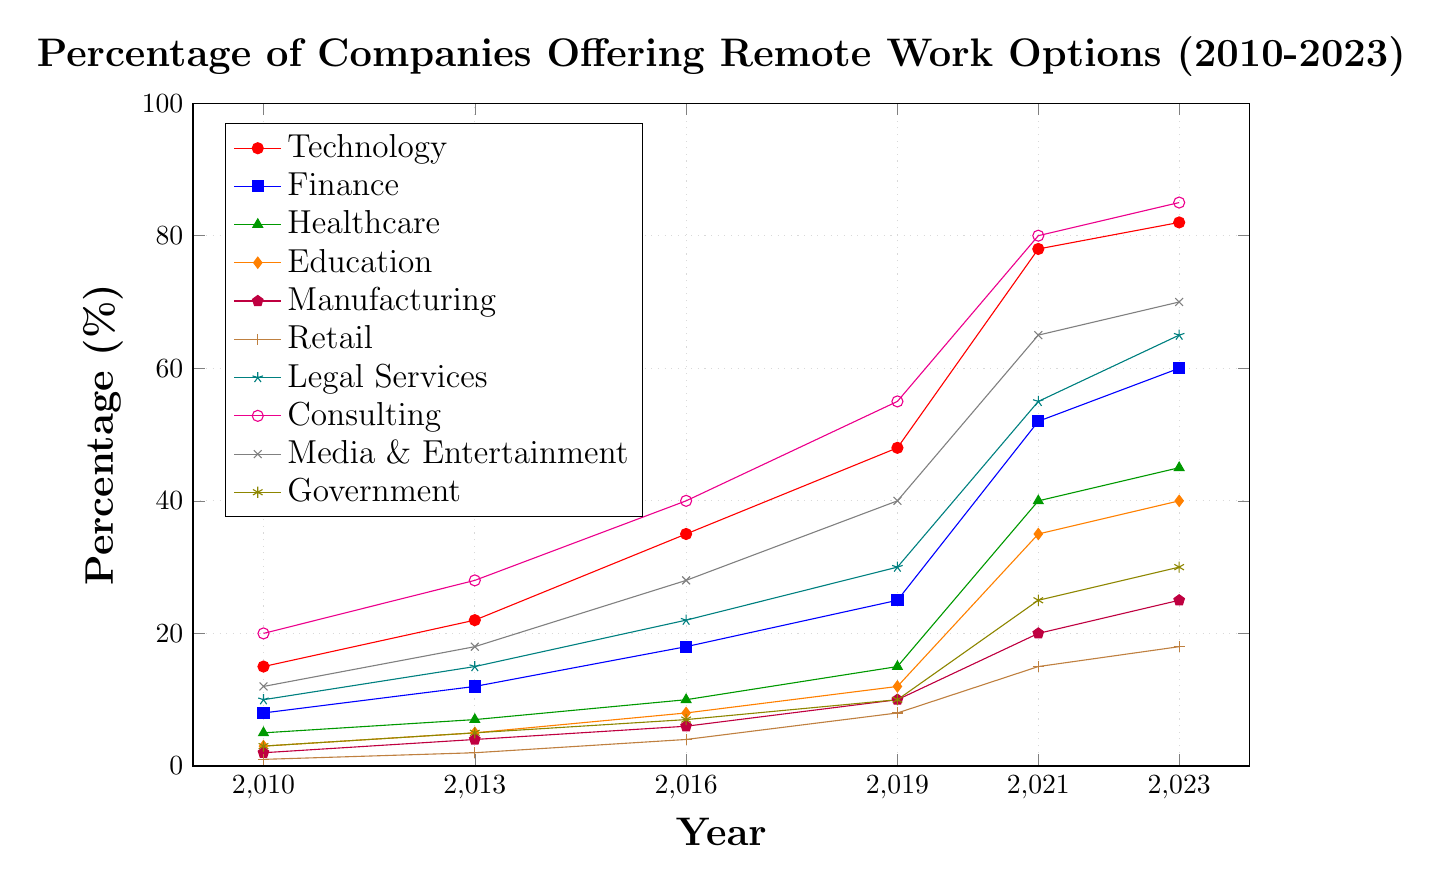Which industry had the highest percentage of companies offering remote work options in 2023? The highest percentage can be identified by looking at the endpoints of the lines for each industry in 2023 and finding the one reaching the highest value on the y-axis. Consulting had the highest value at 85%.
Answer: Consulting How much did the percentage of companies offering remote work options in the Finance industry increase from 2010 to 2023? To find the increase, subtract the percentage in 2010 from the percentage in 2023 for the Finance industry: 60 - 8 = 52%.
Answer: 52% In which year did the Healthcare industry see the most significant percentage increase in companies offering remote work options? By comparing the increases between each pair of years, the largest increment occurred between 2019 and 2021 (40 - 15 = 25%).
Answer: 2019 to 2021 Which two industries had the smallest percentage difference in companies offering remote work options in 2023? Calculate the absolute differences between the percentages for all pairs of industries in 2023, and the smallest difference is between Retail (18%) and Government (30%) with a difference of 12%.
Answer: Retail and Government Which industry showed a steady increase in remote work options every year without any decline or stagnation from 2010 to 2023? An industry with a steady increase would have a continually upward line without any flat or downward segments from 2010 to 2023. Consulting showed this pattern.
Answer: Consulting What is the average percentage of companies offering remote work options in the Education industry across all provided years? Sum the values for Education across all years and divide by the number of years provided: (3 + 5 + 8 + 12 + 35 + 40) / 6 = 103 / 6 ≈ 17.17%.
Answer: 17.17% Which industry had the most significant drop in percentage of companies offering remote work options between any two consecutive periods? Identify drops between consecutive years for all industries. The largest drop was in Media & Entertainment between 2021 (65%) and 2023 (70%) which actually increased, so no industry showed a drop.
Answer: No significant drop How much higher was the percentage of companies offering remote work options in the Technology industry compared to Manufacturing in 2023? Subtract the percentage for Manufacturing from that for Technology in 2023: 82 - 25 = 57%.
Answer: 57% Which industry had the smallest growth in percentage points from 2010 to 2023? Compute the growth for each industry from 2010 to 2023 by subtracting the percentage in 2010 from 2023, and the smallest growth was in Retail (18 - 1 = 17%).
Answer: Retail 